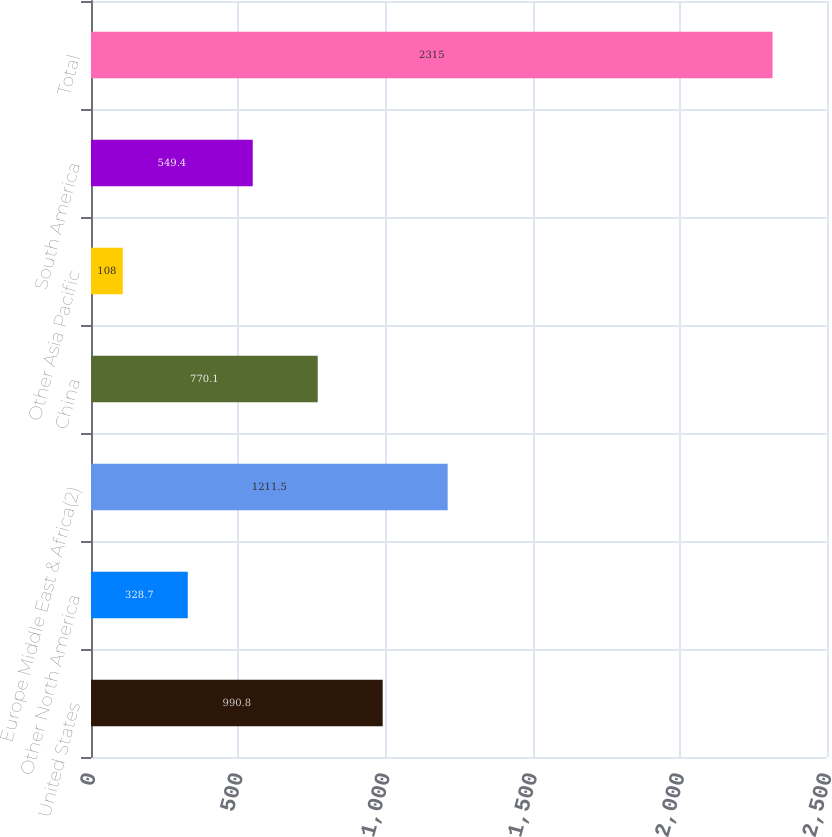<chart> <loc_0><loc_0><loc_500><loc_500><bar_chart><fcel>United States<fcel>Other North America<fcel>Europe Middle East & Africa(2)<fcel>China<fcel>Other Asia Pacific<fcel>South America<fcel>Total<nl><fcel>990.8<fcel>328.7<fcel>1211.5<fcel>770.1<fcel>108<fcel>549.4<fcel>2315<nl></chart> 